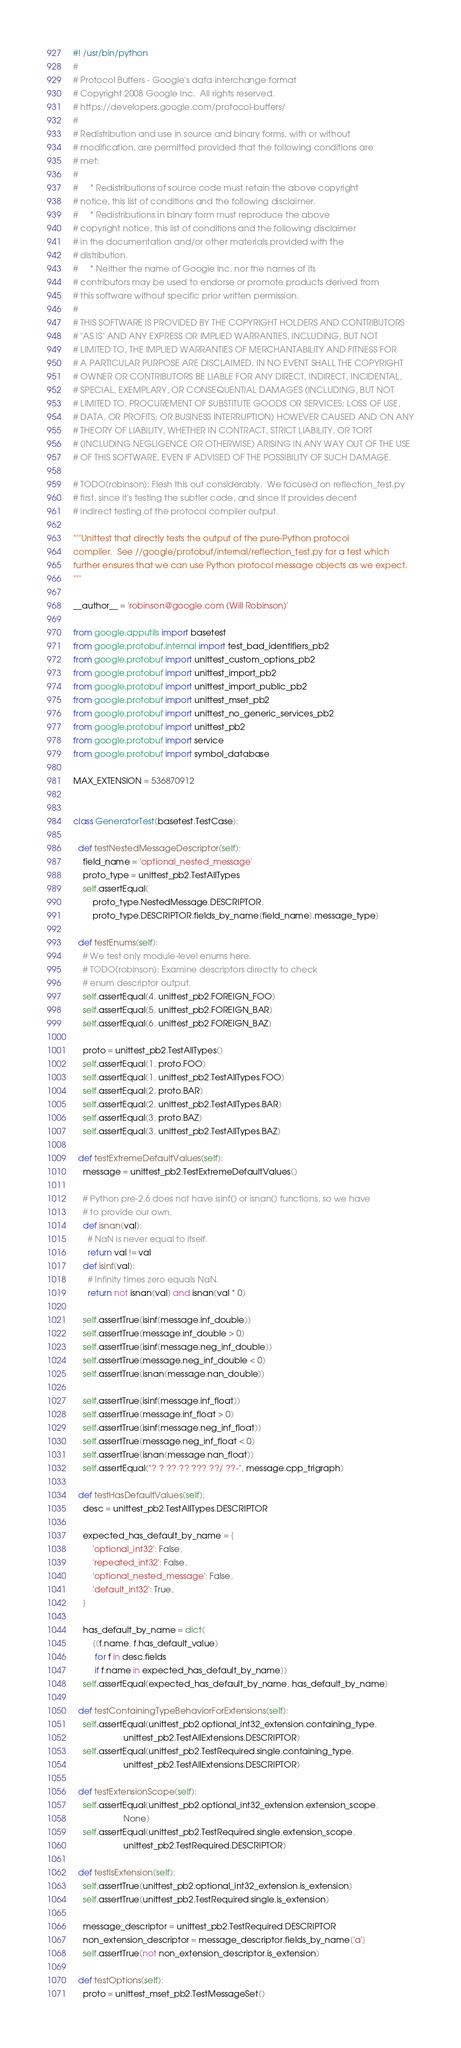<code> <loc_0><loc_0><loc_500><loc_500><_Python_>#! /usr/bin/python
#
# Protocol Buffers - Google's data interchange format
# Copyright 2008 Google Inc.  All rights reserved.
# https://developers.google.com/protocol-buffers/
#
# Redistribution and use in source and binary forms, with or without
# modification, are permitted provided that the following conditions are
# met:
#
#     * Redistributions of source code must retain the above copyright
# notice, this list of conditions and the following disclaimer.
#     * Redistributions in binary form must reproduce the above
# copyright notice, this list of conditions and the following disclaimer
# in the documentation and/or other materials provided with the
# distribution.
#     * Neither the name of Google Inc. nor the names of its
# contributors may be used to endorse or promote products derived from
# this software without specific prior written permission.
#
# THIS SOFTWARE IS PROVIDED BY THE COPYRIGHT HOLDERS AND CONTRIBUTORS
# "AS IS" AND ANY EXPRESS OR IMPLIED WARRANTIES, INCLUDING, BUT NOT
# LIMITED TO, THE IMPLIED WARRANTIES OF MERCHANTABILITY AND FITNESS FOR
# A PARTICULAR PURPOSE ARE DISCLAIMED. IN NO EVENT SHALL THE COPYRIGHT
# OWNER OR CONTRIBUTORS BE LIABLE FOR ANY DIRECT, INDIRECT, INCIDENTAL,
# SPECIAL, EXEMPLARY, OR CONSEQUENTIAL DAMAGES (INCLUDING, BUT NOT
# LIMITED TO, PROCUREMENT OF SUBSTITUTE GOODS OR SERVICES; LOSS OF USE,
# DATA, OR PROFITS; OR BUSINESS INTERRUPTION) HOWEVER CAUSED AND ON ANY
# THEORY OF LIABILITY, WHETHER IN CONTRACT, STRICT LIABILITY, OR TORT
# (INCLUDING NEGLIGENCE OR OTHERWISE) ARISING IN ANY WAY OUT OF THE USE
# OF THIS SOFTWARE, EVEN IF ADVISED OF THE POSSIBILITY OF SUCH DAMAGE.

# TODO(robinson): Flesh this out considerably.  We focused on reflection_test.py
# first, since it's testing the subtler code, and since it provides decent
# indirect testing of the protocol compiler output.

"""Unittest that directly tests the output of the pure-Python protocol
compiler.  See //google/protobuf/internal/reflection_test.py for a test which
further ensures that we can use Python protocol message objects as we expect.
"""

__author__ = 'robinson@google.com (Will Robinson)'

from google.apputils import basetest
from google.protobuf.internal import test_bad_identifiers_pb2
from google.protobuf import unittest_custom_options_pb2
from google.protobuf import unittest_import_pb2
from google.protobuf import unittest_import_public_pb2
from google.protobuf import unittest_mset_pb2
from google.protobuf import unittest_no_generic_services_pb2
from google.protobuf import unittest_pb2
from google.protobuf import service
from google.protobuf import symbol_database

MAX_EXTENSION = 536870912


class GeneratorTest(basetest.TestCase):

  def testNestedMessageDescriptor(self):
    field_name = 'optional_nested_message'
    proto_type = unittest_pb2.TestAllTypes
    self.assertEqual(
        proto_type.NestedMessage.DESCRIPTOR,
        proto_type.DESCRIPTOR.fields_by_name[field_name].message_type)

  def testEnums(self):
    # We test only module-level enums here.
    # TODO(robinson): Examine descriptors directly to check
    # enum descriptor output.
    self.assertEqual(4, unittest_pb2.FOREIGN_FOO)
    self.assertEqual(5, unittest_pb2.FOREIGN_BAR)
    self.assertEqual(6, unittest_pb2.FOREIGN_BAZ)

    proto = unittest_pb2.TestAllTypes()
    self.assertEqual(1, proto.FOO)
    self.assertEqual(1, unittest_pb2.TestAllTypes.FOO)
    self.assertEqual(2, proto.BAR)
    self.assertEqual(2, unittest_pb2.TestAllTypes.BAR)
    self.assertEqual(3, proto.BAZ)
    self.assertEqual(3, unittest_pb2.TestAllTypes.BAZ)

  def testExtremeDefaultValues(self):
    message = unittest_pb2.TestExtremeDefaultValues()

    # Python pre-2.6 does not have isinf() or isnan() functions, so we have
    # to provide our own.
    def isnan(val):
      # NaN is never equal to itself.
      return val != val
    def isinf(val):
      # Infinity times zero equals NaN.
      return not isnan(val) and isnan(val * 0)

    self.assertTrue(isinf(message.inf_double))
    self.assertTrue(message.inf_double > 0)
    self.assertTrue(isinf(message.neg_inf_double))
    self.assertTrue(message.neg_inf_double < 0)
    self.assertTrue(isnan(message.nan_double))

    self.assertTrue(isinf(message.inf_float))
    self.assertTrue(message.inf_float > 0)
    self.assertTrue(isinf(message.neg_inf_float))
    self.assertTrue(message.neg_inf_float < 0)
    self.assertTrue(isnan(message.nan_float))
    self.assertEqual("? ? ?? ?? ??? ??/ ??-", message.cpp_trigraph)

  def testHasDefaultValues(self):
    desc = unittest_pb2.TestAllTypes.DESCRIPTOR

    expected_has_default_by_name = {
        'optional_int32': False,
        'repeated_int32': False,
        'optional_nested_message': False,
        'default_int32': True,
    }

    has_default_by_name = dict(
        [(f.name, f.has_default_value)
         for f in desc.fields
         if f.name in expected_has_default_by_name])
    self.assertEqual(expected_has_default_by_name, has_default_by_name)

  def testContainingTypeBehaviorForExtensions(self):
    self.assertEqual(unittest_pb2.optional_int32_extension.containing_type,
                     unittest_pb2.TestAllExtensions.DESCRIPTOR)
    self.assertEqual(unittest_pb2.TestRequired.single.containing_type,
                     unittest_pb2.TestAllExtensions.DESCRIPTOR)

  def testExtensionScope(self):
    self.assertEqual(unittest_pb2.optional_int32_extension.extension_scope,
                     None)
    self.assertEqual(unittest_pb2.TestRequired.single.extension_scope,
                     unittest_pb2.TestRequired.DESCRIPTOR)

  def testIsExtension(self):
    self.assertTrue(unittest_pb2.optional_int32_extension.is_extension)
    self.assertTrue(unittest_pb2.TestRequired.single.is_extension)

    message_descriptor = unittest_pb2.TestRequired.DESCRIPTOR
    non_extension_descriptor = message_descriptor.fields_by_name['a']
    self.assertTrue(not non_extension_descriptor.is_extension)

  def testOptions(self):
    proto = unittest_mset_pb2.TestMessageSet()</code> 